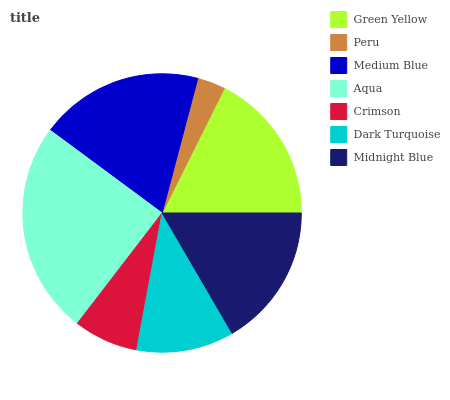Is Peru the minimum?
Answer yes or no. Yes. Is Aqua the maximum?
Answer yes or no. Yes. Is Medium Blue the minimum?
Answer yes or no. No. Is Medium Blue the maximum?
Answer yes or no. No. Is Medium Blue greater than Peru?
Answer yes or no. Yes. Is Peru less than Medium Blue?
Answer yes or no. Yes. Is Peru greater than Medium Blue?
Answer yes or no. No. Is Medium Blue less than Peru?
Answer yes or no. No. Is Midnight Blue the high median?
Answer yes or no. Yes. Is Midnight Blue the low median?
Answer yes or no. Yes. Is Green Yellow the high median?
Answer yes or no. No. Is Dark Turquoise the low median?
Answer yes or no. No. 